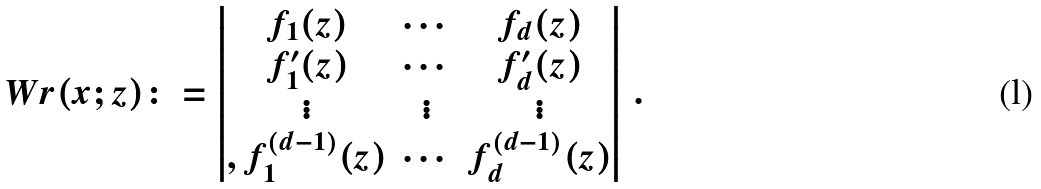Convert formula to latex. <formula><loc_0><loc_0><loc_500><loc_500>\ W r ( x ; z ) \colon = \begin{vmatrix} f _ { 1 } ( z ) & \cdots & f _ { d } ( z ) \\ f _ { 1 } ^ { \prime } ( z ) & \cdots & f _ { d } ^ { \prime } ( z ) \\ \vdots & \vdots & \vdots \\ , f _ { 1 } ^ { ( d - 1 ) } ( z ) & \cdots & f _ { d } ^ { ( d - 1 ) } ( z ) \end{vmatrix} \, .</formula> 